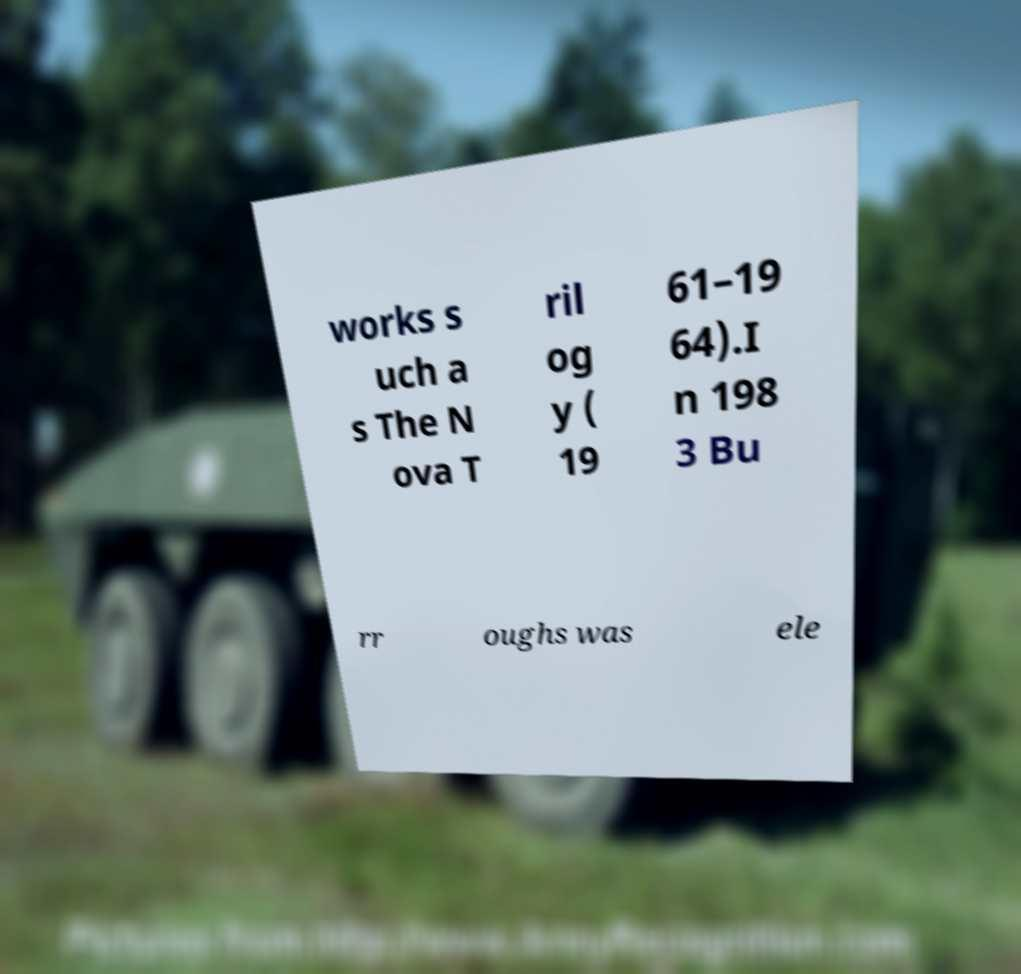Can you accurately transcribe the text from the provided image for me? works s uch a s The N ova T ril og y ( 19 61–19 64).I n 198 3 Bu rr oughs was ele 